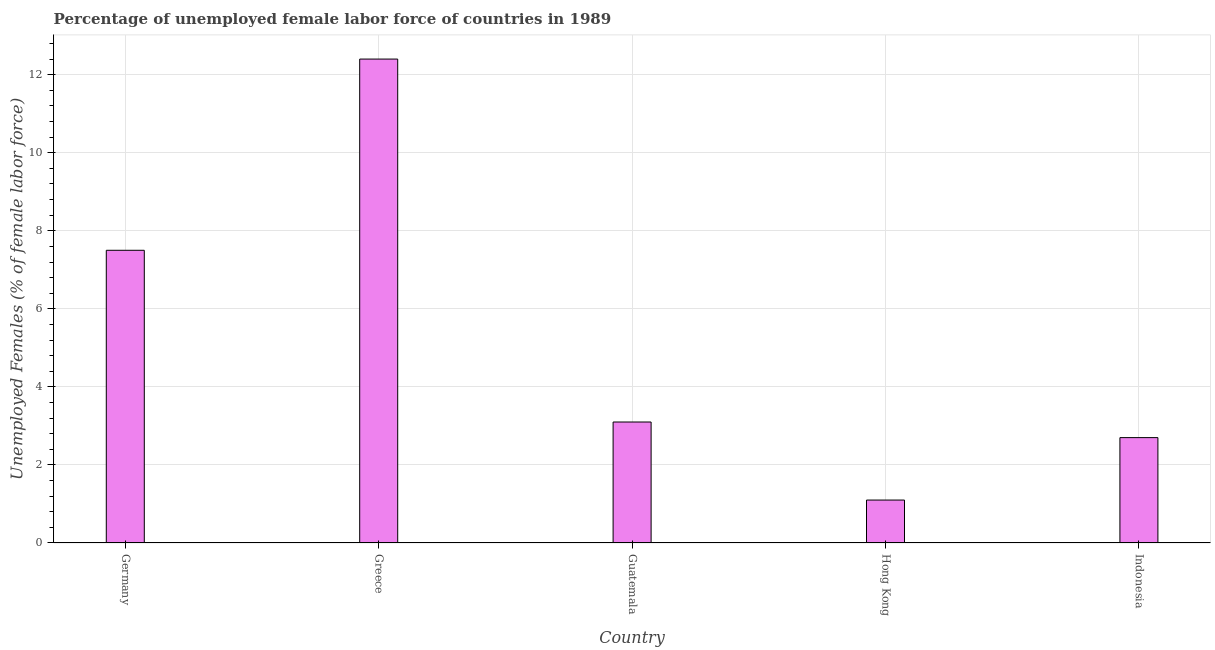What is the title of the graph?
Give a very brief answer. Percentage of unemployed female labor force of countries in 1989. What is the label or title of the X-axis?
Give a very brief answer. Country. What is the label or title of the Y-axis?
Ensure brevity in your answer.  Unemployed Females (% of female labor force). What is the total unemployed female labour force in Indonesia?
Provide a short and direct response. 2.7. Across all countries, what is the maximum total unemployed female labour force?
Offer a very short reply. 12.4. Across all countries, what is the minimum total unemployed female labour force?
Keep it short and to the point. 1.1. In which country was the total unemployed female labour force maximum?
Your answer should be compact. Greece. In which country was the total unemployed female labour force minimum?
Your answer should be very brief. Hong Kong. What is the sum of the total unemployed female labour force?
Make the answer very short. 26.8. What is the difference between the total unemployed female labour force in Germany and Indonesia?
Keep it short and to the point. 4.8. What is the average total unemployed female labour force per country?
Your response must be concise. 5.36. What is the median total unemployed female labour force?
Offer a very short reply. 3.1. In how many countries, is the total unemployed female labour force greater than 10.8 %?
Keep it short and to the point. 1. What is the ratio of the total unemployed female labour force in Guatemala to that in Hong Kong?
Keep it short and to the point. 2.82. What is the difference between the highest and the second highest total unemployed female labour force?
Offer a terse response. 4.9. How many bars are there?
Your answer should be compact. 5. What is the Unemployed Females (% of female labor force) of Germany?
Ensure brevity in your answer.  7.5. What is the Unemployed Females (% of female labor force) of Greece?
Ensure brevity in your answer.  12.4. What is the Unemployed Females (% of female labor force) in Guatemala?
Give a very brief answer. 3.1. What is the Unemployed Females (% of female labor force) in Hong Kong?
Your answer should be compact. 1.1. What is the Unemployed Females (% of female labor force) in Indonesia?
Ensure brevity in your answer.  2.7. What is the difference between the Unemployed Females (% of female labor force) in Germany and Guatemala?
Offer a terse response. 4.4. What is the difference between the Unemployed Females (% of female labor force) in Greece and Hong Kong?
Your answer should be compact. 11.3. What is the difference between the Unemployed Females (% of female labor force) in Greece and Indonesia?
Your response must be concise. 9.7. What is the difference between the Unemployed Females (% of female labor force) in Guatemala and Indonesia?
Ensure brevity in your answer.  0.4. What is the ratio of the Unemployed Females (% of female labor force) in Germany to that in Greece?
Provide a short and direct response. 0.6. What is the ratio of the Unemployed Females (% of female labor force) in Germany to that in Guatemala?
Give a very brief answer. 2.42. What is the ratio of the Unemployed Females (% of female labor force) in Germany to that in Hong Kong?
Your answer should be compact. 6.82. What is the ratio of the Unemployed Females (% of female labor force) in Germany to that in Indonesia?
Your answer should be compact. 2.78. What is the ratio of the Unemployed Females (% of female labor force) in Greece to that in Guatemala?
Keep it short and to the point. 4. What is the ratio of the Unemployed Females (% of female labor force) in Greece to that in Hong Kong?
Provide a short and direct response. 11.27. What is the ratio of the Unemployed Females (% of female labor force) in Greece to that in Indonesia?
Provide a short and direct response. 4.59. What is the ratio of the Unemployed Females (% of female labor force) in Guatemala to that in Hong Kong?
Ensure brevity in your answer.  2.82. What is the ratio of the Unemployed Females (% of female labor force) in Guatemala to that in Indonesia?
Ensure brevity in your answer.  1.15. What is the ratio of the Unemployed Females (% of female labor force) in Hong Kong to that in Indonesia?
Make the answer very short. 0.41. 